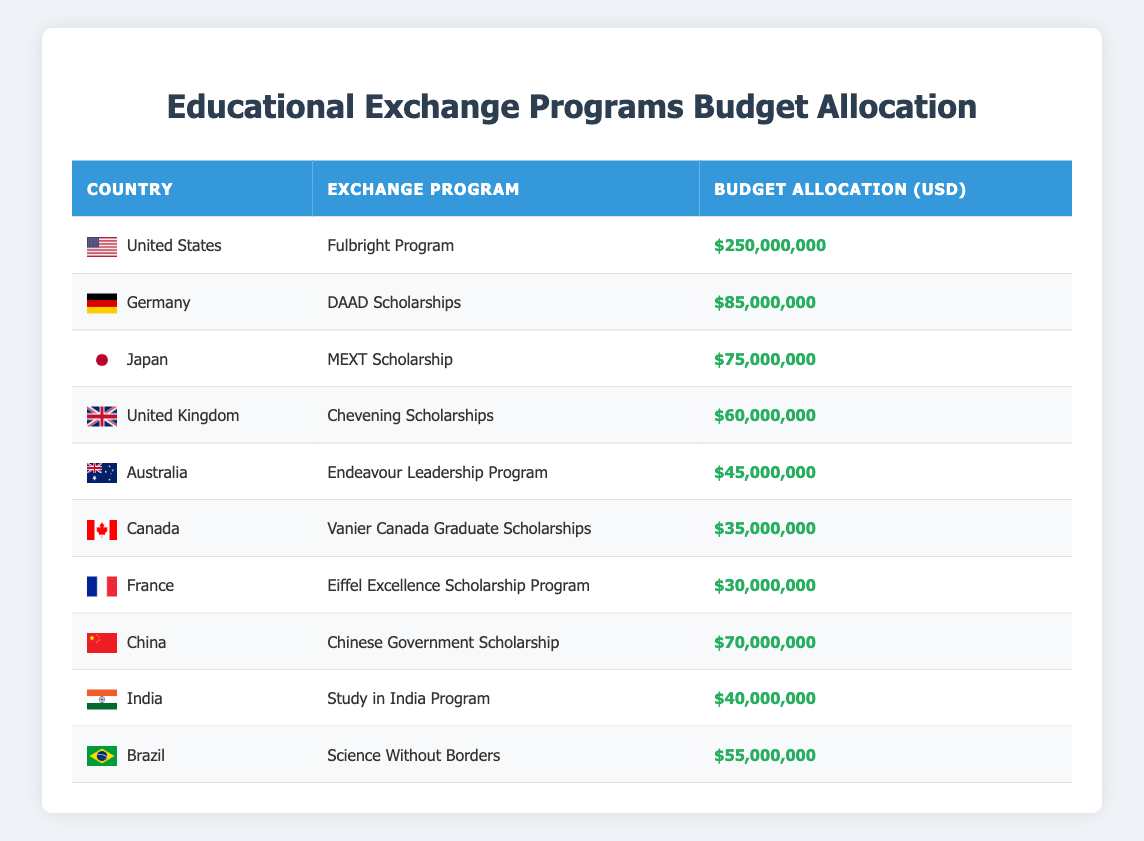What is the budget allocation for the Fulbright Program in the United States? The table shows the allocation for each program under specific countries. By locating the United States in the "Country" column, we can see that the budget for the Fulbright Program is listed in the corresponding row in the "Budget Allocation (USD)" column. This value is 250,000,000 USD.
Answer: 250,000,000 USD Which country's exchange program has the highest budget allocation? To determine this, we can compare all the budget allocations in the table. The Fulbright Program in the United States has the highest allocation, which is 250,000,000 USD, hence the answer.
Answer: United States Calculate the total budget allocation for all listed exchange programs. We need to add the budget allocations for each country listed: 250,000,000 + 85,000,000 + 75,000,000 + 60,000,000 + 45,000,000 + 35,000,000 + 30,000,000 + 70,000,000 + 40,000,000 + 55,000,000 = 645,000,000 USD. This gives us the total budget allocation for all programs.
Answer: 645,000,000 USD Is the budget allocation for the Eiffel Excellence Scholarship Program in France greater than the allocation for the Science Without Borders program in Brazil? The allocation for the Eiffel Excellence Scholarship Program is 30,000,000 USD, while the Science Without Borders program in Brazil has an allocation of 55,000,000 USD. Since 30,000,000 is less than 55,000,000, the statement is false.
Answer: No What is the average budget allocation across all educational initiatives listed? To find the average, we first sum the budget allocations for all countries, which is 645,000,000 USD. We then divide this total by the number of programs, which is 10. Therefore, the average budget allocation is 645,000,000 / 10 = 64,500,000 USD.
Answer: 64,500,000 USD How many countries have total budget allocations exceeding 50,000,000 USD? By looking at each allocation, we can count: the United States, Germany, Japan, the United Kingdom, Brazil, and China all have allocations greater than 50,000,000 USD (6 countries in total).
Answer: 6 Does the budget allocation for the Study in India Program exceed the average budget allocation? The budget for the Study in India Program is 40,000,000 USD. The average budget allocation, as calculated previously, is 64,500,000 USD. Since 40,000,000 is less than 64,500,000, the statement is false.
Answer: No Which exchange programs have budget allocations below 50,000,000 USD? By reviewing the budget allocations, we identify: the Endeavour Leadership Program (45,000,000 USD), Vanier Canada Graduate Scholarships (35,000,000 USD), and the Eiffel Excellence Scholarship Program (30,000,000 USD) as being below 50,000,000 USD.
Answer: Endeavour Leadership Program, Vanier Canada Graduate Scholarships, Eiffel Excellence Scholarship Program 